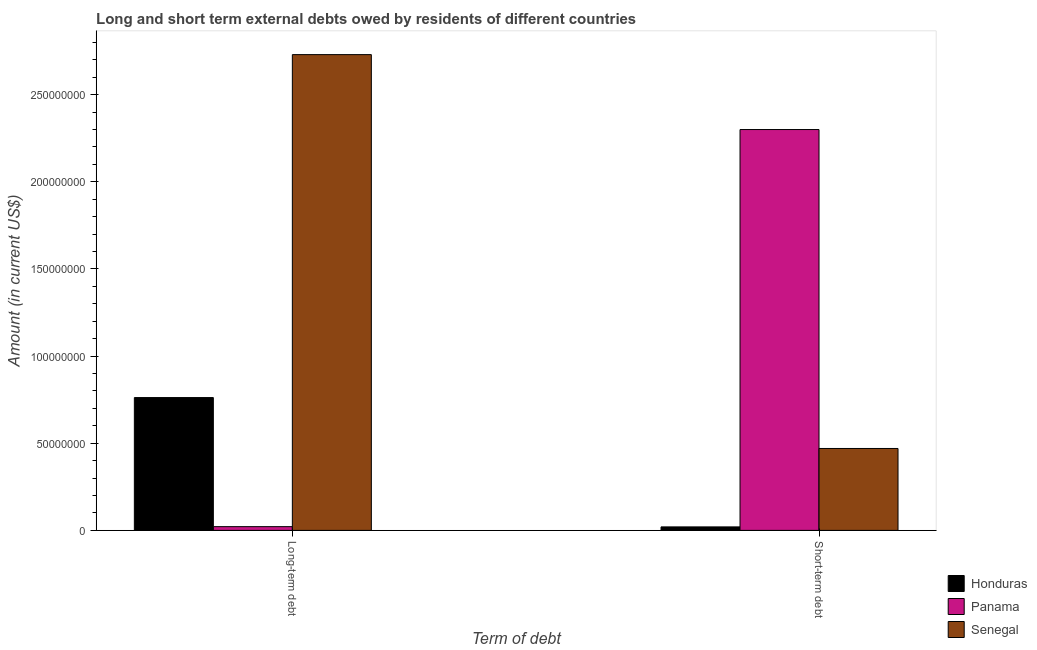How many different coloured bars are there?
Provide a short and direct response. 3. How many groups of bars are there?
Make the answer very short. 2. How many bars are there on the 1st tick from the right?
Make the answer very short. 3. What is the label of the 1st group of bars from the left?
Your answer should be very brief. Long-term debt. What is the short-term debts owed by residents in Panama?
Your answer should be compact. 2.30e+08. Across all countries, what is the maximum long-term debts owed by residents?
Make the answer very short. 2.73e+08. Across all countries, what is the minimum short-term debts owed by residents?
Keep it short and to the point. 2.00e+06. In which country was the short-term debts owed by residents maximum?
Your response must be concise. Panama. In which country was the short-term debts owed by residents minimum?
Provide a short and direct response. Honduras. What is the total short-term debts owed by residents in the graph?
Offer a terse response. 2.79e+08. What is the difference between the long-term debts owed by residents in Panama and that in Senegal?
Keep it short and to the point. -2.71e+08. What is the difference between the short-term debts owed by residents in Senegal and the long-term debts owed by residents in Panama?
Provide a succinct answer. 4.49e+07. What is the average short-term debts owed by residents per country?
Keep it short and to the point. 9.30e+07. What is the difference between the short-term debts owed by residents and long-term debts owed by residents in Senegal?
Ensure brevity in your answer.  -2.26e+08. In how many countries, is the long-term debts owed by residents greater than 80000000 US$?
Give a very brief answer. 1. What is the ratio of the long-term debts owed by residents in Panama to that in Senegal?
Ensure brevity in your answer.  0.01. What does the 1st bar from the left in Short-term debt represents?
Make the answer very short. Honduras. What does the 1st bar from the right in Long-term debt represents?
Provide a succinct answer. Senegal. Are all the bars in the graph horizontal?
Provide a succinct answer. No. What is the difference between two consecutive major ticks on the Y-axis?
Keep it short and to the point. 5.00e+07. Are the values on the major ticks of Y-axis written in scientific E-notation?
Ensure brevity in your answer.  No. Does the graph contain grids?
Provide a short and direct response. No. Where does the legend appear in the graph?
Provide a succinct answer. Bottom right. How many legend labels are there?
Provide a short and direct response. 3. How are the legend labels stacked?
Give a very brief answer. Vertical. What is the title of the graph?
Your answer should be compact. Long and short term external debts owed by residents of different countries. What is the label or title of the X-axis?
Make the answer very short. Term of debt. What is the label or title of the Y-axis?
Provide a short and direct response. Amount (in current US$). What is the Amount (in current US$) of Honduras in Long-term debt?
Your answer should be compact. 7.62e+07. What is the Amount (in current US$) of Panama in Long-term debt?
Ensure brevity in your answer.  2.14e+06. What is the Amount (in current US$) of Senegal in Long-term debt?
Provide a short and direct response. 2.73e+08. What is the Amount (in current US$) of Panama in Short-term debt?
Offer a very short reply. 2.30e+08. What is the Amount (in current US$) of Senegal in Short-term debt?
Provide a succinct answer. 4.70e+07. Across all Term of debt, what is the maximum Amount (in current US$) of Honduras?
Provide a short and direct response. 7.62e+07. Across all Term of debt, what is the maximum Amount (in current US$) in Panama?
Ensure brevity in your answer.  2.30e+08. Across all Term of debt, what is the maximum Amount (in current US$) in Senegal?
Provide a short and direct response. 2.73e+08. Across all Term of debt, what is the minimum Amount (in current US$) of Honduras?
Make the answer very short. 2.00e+06. Across all Term of debt, what is the minimum Amount (in current US$) of Panama?
Your answer should be compact. 2.14e+06. Across all Term of debt, what is the minimum Amount (in current US$) of Senegal?
Provide a short and direct response. 4.70e+07. What is the total Amount (in current US$) in Honduras in the graph?
Keep it short and to the point. 7.82e+07. What is the total Amount (in current US$) of Panama in the graph?
Ensure brevity in your answer.  2.32e+08. What is the total Amount (in current US$) in Senegal in the graph?
Provide a short and direct response. 3.20e+08. What is the difference between the Amount (in current US$) of Honduras in Long-term debt and that in Short-term debt?
Make the answer very short. 7.42e+07. What is the difference between the Amount (in current US$) of Panama in Long-term debt and that in Short-term debt?
Your response must be concise. -2.28e+08. What is the difference between the Amount (in current US$) in Senegal in Long-term debt and that in Short-term debt?
Provide a short and direct response. 2.26e+08. What is the difference between the Amount (in current US$) of Honduras in Long-term debt and the Amount (in current US$) of Panama in Short-term debt?
Your answer should be compact. -1.54e+08. What is the difference between the Amount (in current US$) in Honduras in Long-term debt and the Amount (in current US$) in Senegal in Short-term debt?
Your answer should be very brief. 2.92e+07. What is the difference between the Amount (in current US$) in Panama in Long-term debt and the Amount (in current US$) in Senegal in Short-term debt?
Your answer should be compact. -4.49e+07. What is the average Amount (in current US$) in Honduras per Term of debt?
Your answer should be very brief. 3.91e+07. What is the average Amount (in current US$) of Panama per Term of debt?
Keep it short and to the point. 1.16e+08. What is the average Amount (in current US$) of Senegal per Term of debt?
Make the answer very short. 1.60e+08. What is the difference between the Amount (in current US$) in Honduras and Amount (in current US$) in Panama in Long-term debt?
Your answer should be compact. 7.41e+07. What is the difference between the Amount (in current US$) in Honduras and Amount (in current US$) in Senegal in Long-term debt?
Provide a succinct answer. -1.97e+08. What is the difference between the Amount (in current US$) in Panama and Amount (in current US$) in Senegal in Long-term debt?
Offer a very short reply. -2.71e+08. What is the difference between the Amount (in current US$) in Honduras and Amount (in current US$) in Panama in Short-term debt?
Keep it short and to the point. -2.28e+08. What is the difference between the Amount (in current US$) in Honduras and Amount (in current US$) in Senegal in Short-term debt?
Your answer should be compact. -4.50e+07. What is the difference between the Amount (in current US$) of Panama and Amount (in current US$) of Senegal in Short-term debt?
Offer a very short reply. 1.83e+08. What is the ratio of the Amount (in current US$) of Honduras in Long-term debt to that in Short-term debt?
Provide a succinct answer. 38.1. What is the ratio of the Amount (in current US$) of Panama in Long-term debt to that in Short-term debt?
Make the answer very short. 0.01. What is the ratio of the Amount (in current US$) of Senegal in Long-term debt to that in Short-term debt?
Make the answer very short. 5.81. What is the difference between the highest and the second highest Amount (in current US$) of Honduras?
Make the answer very short. 7.42e+07. What is the difference between the highest and the second highest Amount (in current US$) in Panama?
Keep it short and to the point. 2.28e+08. What is the difference between the highest and the second highest Amount (in current US$) in Senegal?
Provide a short and direct response. 2.26e+08. What is the difference between the highest and the lowest Amount (in current US$) in Honduras?
Your answer should be compact. 7.42e+07. What is the difference between the highest and the lowest Amount (in current US$) of Panama?
Give a very brief answer. 2.28e+08. What is the difference between the highest and the lowest Amount (in current US$) in Senegal?
Provide a succinct answer. 2.26e+08. 